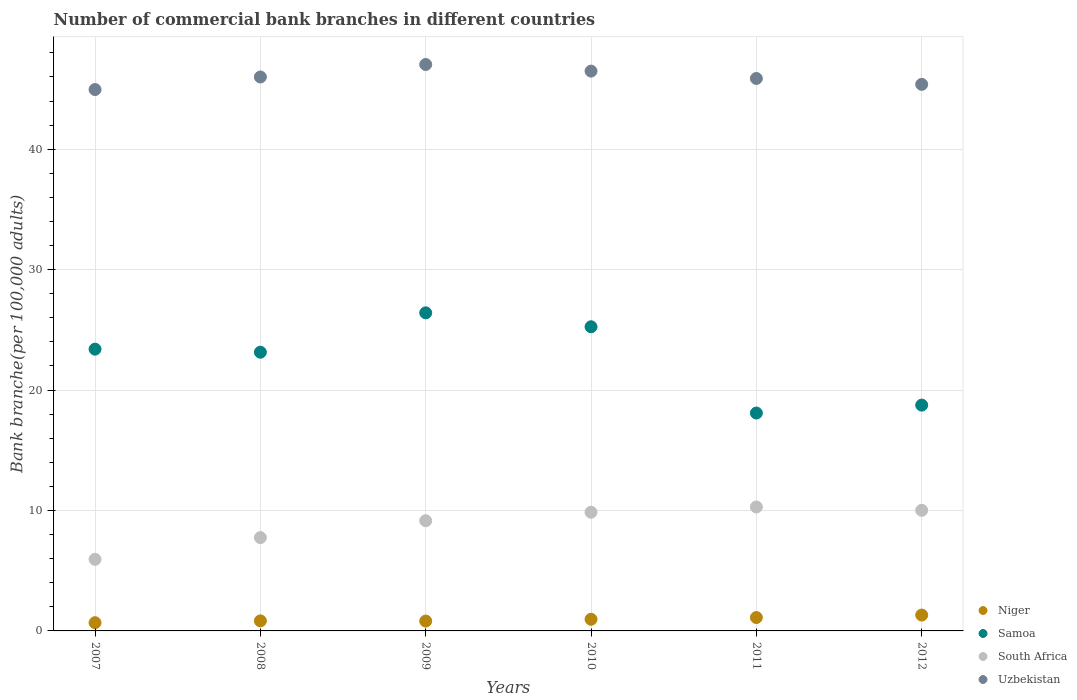How many different coloured dotlines are there?
Your answer should be very brief. 4. What is the number of commercial bank branches in Samoa in 2009?
Make the answer very short. 26.41. Across all years, what is the maximum number of commercial bank branches in Niger?
Your answer should be compact. 1.32. Across all years, what is the minimum number of commercial bank branches in Niger?
Make the answer very short. 0.68. In which year was the number of commercial bank branches in Niger maximum?
Ensure brevity in your answer.  2012. What is the total number of commercial bank branches in Uzbekistan in the graph?
Provide a short and direct response. 275.72. What is the difference between the number of commercial bank branches in South Africa in 2007 and that in 2012?
Your response must be concise. -4.07. What is the difference between the number of commercial bank branches in Samoa in 2010 and the number of commercial bank branches in South Africa in 2012?
Give a very brief answer. 15.24. What is the average number of commercial bank branches in South Africa per year?
Offer a terse response. 8.83. In the year 2009, what is the difference between the number of commercial bank branches in Samoa and number of commercial bank branches in Niger?
Offer a terse response. 25.59. What is the ratio of the number of commercial bank branches in Uzbekistan in 2007 to that in 2008?
Offer a terse response. 0.98. Is the difference between the number of commercial bank branches in Samoa in 2011 and 2012 greater than the difference between the number of commercial bank branches in Niger in 2011 and 2012?
Provide a succinct answer. No. What is the difference between the highest and the second highest number of commercial bank branches in South Africa?
Your answer should be very brief. 0.28. What is the difference between the highest and the lowest number of commercial bank branches in Uzbekistan?
Your answer should be compact. 2.08. Is the sum of the number of commercial bank branches in Uzbekistan in 2009 and 2010 greater than the maximum number of commercial bank branches in South Africa across all years?
Give a very brief answer. Yes. Is the number of commercial bank branches in Niger strictly greater than the number of commercial bank branches in Uzbekistan over the years?
Keep it short and to the point. No. Is the number of commercial bank branches in Uzbekistan strictly less than the number of commercial bank branches in Samoa over the years?
Provide a short and direct response. No. Does the graph contain any zero values?
Provide a succinct answer. No. Does the graph contain grids?
Give a very brief answer. Yes. How are the legend labels stacked?
Your answer should be very brief. Vertical. What is the title of the graph?
Make the answer very short. Number of commercial bank branches in different countries. Does "Croatia" appear as one of the legend labels in the graph?
Give a very brief answer. No. What is the label or title of the Y-axis?
Offer a terse response. Bank branche(per 100,0 adults). What is the Bank branche(per 100,000 adults) in Niger in 2007?
Provide a short and direct response. 0.68. What is the Bank branche(per 100,000 adults) of Samoa in 2007?
Give a very brief answer. 23.4. What is the Bank branche(per 100,000 adults) in South Africa in 2007?
Provide a short and direct response. 5.94. What is the Bank branche(per 100,000 adults) of Uzbekistan in 2007?
Give a very brief answer. 44.95. What is the Bank branche(per 100,000 adults) in Niger in 2008?
Your response must be concise. 0.83. What is the Bank branche(per 100,000 adults) in Samoa in 2008?
Offer a very short reply. 23.14. What is the Bank branche(per 100,000 adults) in South Africa in 2008?
Offer a terse response. 7.75. What is the Bank branche(per 100,000 adults) in Uzbekistan in 2008?
Give a very brief answer. 46. What is the Bank branche(per 100,000 adults) in Niger in 2009?
Offer a very short reply. 0.82. What is the Bank branche(per 100,000 adults) of Samoa in 2009?
Provide a short and direct response. 26.41. What is the Bank branche(per 100,000 adults) in South Africa in 2009?
Your answer should be very brief. 9.15. What is the Bank branche(per 100,000 adults) of Uzbekistan in 2009?
Provide a short and direct response. 47.03. What is the Bank branche(per 100,000 adults) of Niger in 2010?
Your answer should be very brief. 0.97. What is the Bank branche(per 100,000 adults) of Samoa in 2010?
Give a very brief answer. 25.26. What is the Bank branche(per 100,000 adults) of South Africa in 2010?
Make the answer very short. 9.85. What is the Bank branche(per 100,000 adults) in Uzbekistan in 2010?
Make the answer very short. 46.48. What is the Bank branche(per 100,000 adults) of Niger in 2011?
Offer a very short reply. 1.11. What is the Bank branche(per 100,000 adults) of Samoa in 2011?
Provide a short and direct response. 18.09. What is the Bank branche(per 100,000 adults) of South Africa in 2011?
Provide a short and direct response. 10.29. What is the Bank branche(per 100,000 adults) of Uzbekistan in 2011?
Provide a succinct answer. 45.87. What is the Bank branche(per 100,000 adults) in Niger in 2012?
Your answer should be compact. 1.32. What is the Bank branche(per 100,000 adults) in Samoa in 2012?
Provide a short and direct response. 18.75. What is the Bank branche(per 100,000 adults) in South Africa in 2012?
Your answer should be compact. 10.01. What is the Bank branche(per 100,000 adults) of Uzbekistan in 2012?
Your answer should be very brief. 45.38. Across all years, what is the maximum Bank branche(per 100,000 adults) of Niger?
Keep it short and to the point. 1.32. Across all years, what is the maximum Bank branche(per 100,000 adults) in Samoa?
Provide a short and direct response. 26.41. Across all years, what is the maximum Bank branche(per 100,000 adults) of South Africa?
Keep it short and to the point. 10.29. Across all years, what is the maximum Bank branche(per 100,000 adults) in Uzbekistan?
Provide a succinct answer. 47.03. Across all years, what is the minimum Bank branche(per 100,000 adults) of Niger?
Give a very brief answer. 0.68. Across all years, what is the minimum Bank branche(per 100,000 adults) in Samoa?
Offer a terse response. 18.09. Across all years, what is the minimum Bank branche(per 100,000 adults) in South Africa?
Your answer should be compact. 5.94. Across all years, what is the minimum Bank branche(per 100,000 adults) in Uzbekistan?
Make the answer very short. 44.95. What is the total Bank branche(per 100,000 adults) of Niger in the graph?
Offer a terse response. 5.73. What is the total Bank branche(per 100,000 adults) in Samoa in the graph?
Your answer should be compact. 135.05. What is the total Bank branche(per 100,000 adults) of South Africa in the graph?
Provide a short and direct response. 53. What is the total Bank branche(per 100,000 adults) in Uzbekistan in the graph?
Offer a terse response. 275.72. What is the difference between the Bank branche(per 100,000 adults) in Niger in 2007 and that in 2008?
Provide a short and direct response. -0.15. What is the difference between the Bank branche(per 100,000 adults) in Samoa in 2007 and that in 2008?
Your answer should be very brief. 0.26. What is the difference between the Bank branche(per 100,000 adults) of South Africa in 2007 and that in 2008?
Your answer should be very brief. -1.8. What is the difference between the Bank branche(per 100,000 adults) in Uzbekistan in 2007 and that in 2008?
Your answer should be very brief. -1.04. What is the difference between the Bank branche(per 100,000 adults) of Niger in 2007 and that in 2009?
Offer a terse response. -0.14. What is the difference between the Bank branche(per 100,000 adults) of Samoa in 2007 and that in 2009?
Your answer should be compact. -3.02. What is the difference between the Bank branche(per 100,000 adults) in South Africa in 2007 and that in 2009?
Your response must be concise. -3.2. What is the difference between the Bank branche(per 100,000 adults) of Uzbekistan in 2007 and that in 2009?
Your response must be concise. -2.08. What is the difference between the Bank branche(per 100,000 adults) in Niger in 2007 and that in 2010?
Your response must be concise. -0.28. What is the difference between the Bank branche(per 100,000 adults) in Samoa in 2007 and that in 2010?
Your answer should be very brief. -1.86. What is the difference between the Bank branche(per 100,000 adults) in South Africa in 2007 and that in 2010?
Keep it short and to the point. -3.91. What is the difference between the Bank branche(per 100,000 adults) of Uzbekistan in 2007 and that in 2010?
Your answer should be compact. -1.53. What is the difference between the Bank branche(per 100,000 adults) in Niger in 2007 and that in 2011?
Make the answer very short. -0.43. What is the difference between the Bank branche(per 100,000 adults) of Samoa in 2007 and that in 2011?
Make the answer very short. 5.31. What is the difference between the Bank branche(per 100,000 adults) in South Africa in 2007 and that in 2011?
Offer a very short reply. -4.35. What is the difference between the Bank branche(per 100,000 adults) of Uzbekistan in 2007 and that in 2011?
Your answer should be compact. -0.92. What is the difference between the Bank branche(per 100,000 adults) of Niger in 2007 and that in 2012?
Offer a terse response. -0.64. What is the difference between the Bank branche(per 100,000 adults) in Samoa in 2007 and that in 2012?
Make the answer very short. 4.65. What is the difference between the Bank branche(per 100,000 adults) in South Africa in 2007 and that in 2012?
Give a very brief answer. -4.07. What is the difference between the Bank branche(per 100,000 adults) of Uzbekistan in 2007 and that in 2012?
Keep it short and to the point. -0.43. What is the difference between the Bank branche(per 100,000 adults) of Niger in 2008 and that in 2009?
Provide a short and direct response. 0.02. What is the difference between the Bank branche(per 100,000 adults) in Samoa in 2008 and that in 2009?
Make the answer very short. -3.27. What is the difference between the Bank branche(per 100,000 adults) in South Africa in 2008 and that in 2009?
Give a very brief answer. -1.4. What is the difference between the Bank branche(per 100,000 adults) in Uzbekistan in 2008 and that in 2009?
Offer a very short reply. -1.04. What is the difference between the Bank branche(per 100,000 adults) of Niger in 2008 and that in 2010?
Offer a terse response. -0.13. What is the difference between the Bank branche(per 100,000 adults) of Samoa in 2008 and that in 2010?
Provide a short and direct response. -2.11. What is the difference between the Bank branche(per 100,000 adults) in South Africa in 2008 and that in 2010?
Your answer should be very brief. -2.11. What is the difference between the Bank branche(per 100,000 adults) in Uzbekistan in 2008 and that in 2010?
Your answer should be very brief. -0.49. What is the difference between the Bank branche(per 100,000 adults) of Niger in 2008 and that in 2011?
Keep it short and to the point. -0.28. What is the difference between the Bank branche(per 100,000 adults) of Samoa in 2008 and that in 2011?
Make the answer very short. 5.05. What is the difference between the Bank branche(per 100,000 adults) of South Africa in 2008 and that in 2011?
Your response must be concise. -2.54. What is the difference between the Bank branche(per 100,000 adults) in Uzbekistan in 2008 and that in 2011?
Offer a terse response. 0.12. What is the difference between the Bank branche(per 100,000 adults) in Niger in 2008 and that in 2012?
Offer a very short reply. -0.48. What is the difference between the Bank branche(per 100,000 adults) of Samoa in 2008 and that in 2012?
Provide a short and direct response. 4.39. What is the difference between the Bank branche(per 100,000 adults) of South Africa in 2008 and that in 2012?
Provide a short and direct response. -2.27. What is the difference between the Bank branche(per 100,000 adults) of Uzbekistan in 2008 and that in 2012?
Give a very brief answer. 0.61. What is the difference between the Bank branche(per 100,000 adults) of Niger in 2009 and that in 2010?
Your answer should be compact. -0.15. What is the difference between the Bank branche(per 100,000 adults) in Samoa in 2009 and that in 2010?
Make the answer very short. 1.16. What is the difference between the Bank branche(per 100,000 adults) in South Africa in 2009 and that in 2010?
Offer a very short reply. -0.71. What is the difference between the Bank branche(per 100,000 adults) of Uzbekistan in 2009 and that in 2010?
Provide a succinct answer. 0.55. What is the difference between the Bank branche(per 100,000 adults) of Niger in 2009 and that in 2011?
Keep it short and to the point. -0.29. What is the difference between the Bank branche(per 100,000 adults) in Samoa in 2009 and that in 2011?
Your answer should be compact. 8.32. What is the difference between the Bank branche(per 100,000 adults) in South Africa in 2009 and that in 2011?
Keep it short and to the point. -1.14. What is the difference between the Bank branche(per 100,000 adults) in Uzbekistan in 2009 and that in 2011?
Make the answer very short. 1.16. What is the difference between the Bank branche(per 100,000 adults) of Niger in 2009 and that in 2012?
Provide a succinct answer. -0.5. What is the difference between the Bank branche(per 100,000 adults) of Samoa in 2009 and that in 2012?
Your answer should be very brief. 7.66. What is the difference between the Bank branche(per 100,000 adults) of South Africa in 2009 and that in 2012?
Offer a terse response. -0.87. What is the difference between the Bank branche(per 100,000 adults) in Uzbekistan in 2009 and that in 2012?
Give a very brief answer. 1.65. What is the difference between the Bank branche(per 100,000 adults) of Niger in 2010 and that in 2011?
Provide a succinct answer. -0.15. What is the difference between the Bank branche(per 100,000 adults) of Samoa in 2010 and that in 2011?
Offer a very short reply. 7.16. What is the difference between the Bank branche(per 100,000 adults) in South Africa in 2010 and that in 2011?
Offer a very short reply. -0.44. What is the difference between the Bank branche(per 100,000 adults) in Uzbekistan in 2010 and that in 2011?
Provide a succinct answer. 0.61. What is the difference between the Bank branche(per 100,000 adults) of Niger in 2010 and that in 2012?
Your answer should be very brief. -0.35. What is the difference between the Bank branche(per 100,000 adults) of Samoa in 2010 and that in 2012?
Ensure brevity in your answer.  6.51. What is the difference between the Bank branche(per 100,000 adults) in South Africa in 2010 and that in 2012?
Your answer should be compact. -0.16. What is the difference between the Bank branche(per 100,000 adults) of Uzbekistan in 2010 and that in 2012?
Offer a very short reply. 1.1. What is the difference between the Bank branche(per 100,000 adults) of Niger in 2011 and that in 2012?
Provide a short and direct response. -0.2. What is the difference between the Bank branche(per 100,000 adults) in Samoa in 2011 and that in 2012?
Provide a succinct answer. -0.66. What is the difference between the Bank branche(per 100,000 adults) of South Africa in 2011 and that in 2012?
Give a very brief answer. 0.28. What is the difference between the Bank branche(per 100,000 adults) of Uzbekistan in 2011 and that in 2012?
Provide a short and direct response. 0.49. What is the difference between the Bank branche(per 100,000 adults) in Niger in 2007 and the Bank branche(per 100,000 adults) in Samoa in 2008?
Provide a short and direct response. -22.46. What is the difference between the Bank branche(per 100,000 adults) in Niger in 2007 and the Bank branche(per 100,000 adults) in South Africa in 2008?
Your answer should be very brief. -7.07. What is the difference between the Bank branche(per 100,000 adults) in Niger in 2007 and the Bank branche(per 100,000 adults) in Uzbekistan in 2008?
Offer a very short reply. -45.31. What is the difference between the Bank branche(per 100,000 adults) of Samoa in 2007 and the Bank branche(per 100,000 adults) of South Africa in 2008?
Provide a succinct answer. 15.65. What is the difference between the Bank branche(per 100,000 adults) of Samoa in 2007 and the Bank branche(per 100,000 adults) of Uzbekistan in 2008?
Your answer should be compact. -22.6. What is the difference between the Bank branche(per 100,000 adults) in South Africa in 2007 and the Bank branche(per 100,000 adults) in Uzbekistan in 2008?
Offer a terse response. -40.05. What is the difference between the Bank branche(per 100,000 adults) of Niger in 2007 and the Bank branche(per 100,000 adults) of Samoa in 2009?
Provide a short and direct response. -25.73. What is the difference between the Bank branche(per 100,000 adults) of Niger in 2007 and the Bank branche(per 100,000 adults) of South Africa in 2009?
Provide a short and direct response. -8.47. What is the difference between the Bank branche(per 100,000 adults) in Niger in 2007 and the Bank branche(per 100,000 adults) in Uzbekistan in 2009?
Keep it short and to the point. -46.35. What is the difference between the Bank branche(per 100,000 adults) in Samoa in 2007 and the Bank branche(per 100,000 adults) in South Africa in 2009?
Your answer should be compact. 14.25. What is the difference between the Bank branche(per 100,000 adults) of Samoa in 2007 and the Bank branche(per 100,000 adults) of Uzbekistan in 2009?
Provide a succinct answer. -23.64. What is the difference between the Bank branche(per 100,000 adults) in South Africa in 2007 and the Bank branche(per 100,000 adults) in Uzbekistan in 2009?
Keep it short and to the point. -41.09. What is the difference between the Bank branche(per 100,000 adults) in Niger in 2007 and the Bank branche(per 100,000 adults) in Samoa in 2010?
Provide a succinct answer. -24.57. What is the difference between the Bank branche(per 100,000 adults) in Niger in 2007 and the Bank branche(per 100,000 adults) in South Africa in 2010?
Your response must be concise. -9.17. What is the difference between the Bank branche(per 100,000 adults) in Niger in 2007 and the Bank branche(per 100,000 adults) in Uzbekistan in 2010?
Give a very brief answer. -45.8. What is the difference between the Bank branche(per 100,000 adults) in Samoa in 2007 and the Bank branche(per 100,000 adults) in South Africa in 2010?
Make the answer very short. 13.54. What is the difference between the Bank branche(per 100,000 adults) of Samoa in 2007 and the Bank branche(per 100,000 adults) of Uzbekistan in 2010?
Your response must be concise. -23.09. What is the difference between the Bank branche(per 100,000 adults) in South Africa in 2007 and the Bank branche(per 100,000 adults) in Uzbekistan in 2010?
Give a very brief answer. -40.54. What is the difference between the Bank branche(per 100,000 adults) of Niger in 2007 and the Bank branche(per 100,000 adults) of Samoa in 2011?
Make the answer very short. -17.41. What is the difference between the Bank branche(per 100,000 adults) of Niger in 2007 and the Bank branche(per 100,000 adults) of South Africa in 2011?
Provide a short and direct response. -9.61. What is the difference between the Bank branche(per 100,000 adults) of Niger in 2007 and the Bank branche(per 100,000 adults) of Uzbekistan in 2011?
Provide a short and direct response. -45.19. What is the difference between the Bank branche(per 100,000 adults) of Samoa in 2007 and the Bank branche(per 100,000 adults) of South Africa in 2011?
Provide a succinct answer. 13.11. What is the difference between the Bank branche(per 100,000 adults) in Samoa in 2007 and the Bank branche(per 100,000 adults) in Uzbekistan in 2011?
Make the answer very short. -22.48. What is the difference between the Bank branche(per 100,000 adults) of South Africa in 2007 and the Bank branche(per 100,000 adults) of Uzbekistan in 2011?
Offer a terse response. -39.93. What is the difference between the Bank branche(per 100,000 adults) of Niger in 2007 and the Bank branche(per 100,000 adults) of Samoa in 2012?
Provide a short and direct response. -18.07. What is the difference between the Bank branche(per 100,000 adults) in Niger in 2007 and the Bank branche(per 100,000 adults) in South Africa in 2012?
Your answer should be compact. -9.33. What is the difference between the Bank branche(per 100,000 adults) in Niger in 2007 and the Bank branche(per 100,000 adults) in Uzbekistan in 2012?
Offer a terse response. -44.7. What is the difference between the Bank branche(per 100,000 adults) of Samoa in 2007 and the Bank branche(per 100,000 adults) of South Africa in 2012?
Provide a short and direct response. 13.38. What is the difference between the Bank branche(per 100,000 adults) in Samoa in 2007 and the Bank branche(per 100,000 adults) in Uzbekistan in 2012?
Your response must be concise. -21.99. What is the difference between the Bank branche(per 100,000 adults) in South Africa in 2007 and the Bank branche(per 100,000 adults) in Uzbekistan in 2012?
Keep it short and to the point. -39.44. What is the difference between the Bank branche(per 100,000 adults) of Niger in 2008 and the Bank branche(per 100,000 adults) of Samoa in 2009?
Provide a succinct answer. -25.58. What is the difference between the Bank branche(per 100,000 adults) of Niger in 2008 and the Bank branche(per 100,000 adults) of South Africa in 2009?
Provide a short and direct response. -8.31. What is the difference between the Bank branche(per 100,000 adults) in Niger in 2008 and the Bank branche(per 100,000 adults) in Uzbekistan in 2009?
Offer a very short reply. -46.2. What is the difference between the Bank branche(per 100,000 adults) in Samoa in 2008 and the Bank branche(per 100,000 adults) in South Africa in 2009?
Make the answer very short. 13.99. What is the difference between the Bank branche(per 100,000 adults) of Samoa in 2008 and the Bank branche(per 100,000 adults) of Uzbekistan in 2009?
Your response must be concise. -23.89. What is the difference between the Bank branche(per 100,000 adults) in South Africa in 2008 and the Bank branche(per 100,000 adults) in Uzbekistan in 2009?
Give a very brief answer. -39.29. What is the difference between the Bank branche(per 100,000 adults) of Niger in 2008 and the Bank branche(per 100,000 adults) of Samoa in 2010?
Give a very brief answer. -24.42. What is the difference between the Bank branche(per 100,000 adults) of Niger in 2008 and the Bank branche(per 100,000 adults) of South Africa in 2010?
Give a very brief answer. -9.02. What is the difference between the Bank branche(per 100,000 adults) of Niger in 2008 and the Bank branche(per 100,000 adults) of Uzbekistan in 2010?
Provide a short and direct response. -45.65. What is the difference between the Bank branche(per 100,000 adults) in Samoa in 2008 and the Bank branche(per 100,000 adults) in South Africa in 2010?
Keep it short and to the point. 13.29. What is the difference between the Bank branche(per 100,000 adults) of Samoa in 2008 and the Bank branche(per 100,000 adults) of Uzbekistan in 2010?
Offer a terse response. -23.34. What is the difference between the Bank branche(per 100,000 adults) of South Africa in 2008 and the Bank branche(per 100,000 adults) of Uzbekistan in 2010?
Give a very brief answer. -38.73. What is the difference between the Bank branche(per 100,000 adults) of Niger in 2008 and the Bank branche(per 100,000 adults) of Samoa in 2011?
Offer a very short reply. -17.26. What is the difference between the Bank branche(per 100,000 adults) in Niger in 2008 and the Bank branche(per 100,000 adults) in South Africa in 2011?
Keep it short and to the point. -9.46. What is the difference between the Bank branche(per 100,000 adults) in Niger in 2008 and the Bank branche(per 100,000 adults) in Uzbekistan in 2011?
Keep it short and to the point. -45.04. What is the difference between the Bank branche(per 100,000 adults) of Samoa in 2008 and the Bank branche(per 100,000 adults) of South Africa in 2011?
Make the answer very short. 12.85. What is the difference between the Bank branche(per 100,000 adults) of Samoa in 2008 and the Bank branche(per 100,000 adults) of Uzbekistan in 2011?
Provide a succinct answer. -22.73. What is the difference between the Bank branche(per 100,000 adults) of South Africa in 2008 and the Bank branche(per 100,000 adults) of Uzbekistan in 2011?
Give a very brief answer. -38.12. What is the difference between the Bank branche(per 100,000 adults) in Niger in 2008 and the Bank branche(per 100,000 adults) in Samoa in 2012?
Make the answer very short. -17.92. What is the difference between the Bank branche(per 100,000 adults) of Niger in 2008 and the Bank branche(per 100,000 adults) of South Africa in 2012?
Your answer should be compact. -9.18. What is the difference between the Bank branche(per 100,000 adults) of Niger in 2008 and the Bank branche(per 100,000 adults) of Uzbekistan in 2012?
Offer a terse response. -44.55. What is the difference between the Bank branche(per 100,000 adults) of Samoa in 2008 and the Bank branche(per 100,000 adults) of South Africa in 2012?
Offer a terse response. 13.13. What is the difference between the Bank branche(per 100,000 adults) in Samoa in 2008 and the Bank branche(per 100,000 adults) in Uzbekistan in 2012?
Ensure brevity in your answer.  -22.24. What is the difference between the Bank branche(per 100,000 adults) in South Africa in 2008 and the Bank branche(per 100,000 adults) in Uzbekistan in 2012?
Provide a short and direct response. -37.64. What is the difference between the Bank branche(per 100,000 adults) of Niger in 2009 and the Bank branche(per 100,000 adults) of Samoa in 2010?
Your response must be concise. -24.44. What is the difference between the Bank branche(per 100,000 adults) in Niger in 2009 and the Bank branche(per 100,000 adults) in South Africa in 2010?
Make the answer very short. -9.04. What is the difference between the Bank branche(per 100,000 adults) in Niger in 2009 and the Bank branche(per 100,000 adults) in Uzbekistan in 2010?
Offer a terse response. -45.66. What is the difference between the Bank branche(per 100,000 adults) in Samoa in 2009 and the Bank branche(per 100,000 adults) in South Africa in 2010?
Keep it short and to the point. 16.56. What is the difference between the Bank branche(per 100,000 adults) in Samoa in 2009 and the Bank branche(per 100,000 adults) in Uzbekistan in 2010?
Offer a terse response. -20.07. What is the difference between the Bank branche(per 100,000 adults) of South Africa in 2009 and the Bank branche(per 100,000 adults) of Uzbekistan in 2010?
Offer a very short reply. -37.34. What is the difference between the Bank branche(per 100,000 adults) in Niger in 2009 and the Bank branche(per 100,000 adults) in Samoa in 2011?
Offer a very short reply. -17.27. What is the difference between the Bank branche(per 100,000 adults) in Niger in 2009 and the Bank branche(per 100,000 adults) in South Africa in 2011?
Ensure brevity in your answer.  -9.47. What is the difference between the Bank branche(per 100,000 adults) of Niger in 2009 and the Bank branche(per 100,000 adults) of Uzbekistan in 2011?
Provide a succinct answer. -45.05. What is the difference between the Bank branche(per 100,000 adults) in Samoa in 2009 and the Bank branche(per 100,000 adults) in South Africa in 2011?
Provide a succinct answer. 16.12. What is the difference between the Bank branche(per 100,000 adults) in Samoa in 2009 and the Bank branche(per 100,000 adults) in Uzbekistan in 2011?
Your answer should be compact. -19.46. What is the difference between the Bank branche(per 100,000 adults) of South Africa in 2009 and the Bank branche(per 100,000 adults) of Uzbekistan in 2011?
Your response must be concise. -36.73. What is the difference between the Bank branche(per 100,000 adults) of Niger in 2009 and the Bank branche(per 100,000 adults) of Samoa in 2012?
Your response must be concise. -17.93. What is the difference between the Bank branche(per 100,000 adults) in Niger in 2009 and the Bank branche(per 100,000 adults) in South Africa in 2012?
Offer a very short reply. -9.2. What is the difference between the Bank branche(per 100,000 adults) in Niger in 2009 and the Bank branche(per 100,000 adults) in Uzbekistan in 2012?
Provide a short and direct response. -44.57. What is the difference between the Bank branche(per 100,000 adults) of Samoa in 2009 and the Bank branche(per 100,000 adults) of South Africa in 2012?
Provide a short and direct response. 16.4. What is the difference between the Bank branche(per 100,000 adults) in Samoa in 2009 and the Bank branche(per 100,000 adults) in Uzbekistan in 2012?
Offer a very short reply. -18.97. What is the difference between the Bank branche(per 100,000 adults) of South Africa in 2009 and the Bank branche(per 100,000 adults) of Uzbekistan in 2012?
Offer a terse response. -36.24. What is the difference between the Bank branche(per 100,000 adults) of Niger in 2010 and the Bank branche(per 100,000 adults) of Samoa in 2011?
Your response must be concise. -17.13. What is the difference between the Bank branche(per 100,000 adults) in Niger in 2010 and the Bank branche(per 100,000 adults) in South Africa in 2011?
Offer a terse response. -9.33. What is the difference between the Bank branche(per 100,000 adults) in Niger in 2010 and the Bank branche(per 100,000 adults) in Uzbekistan in 2011?
Ensure brevity in your answer.  -44.91. What is the difference between the Bank branche(per 100,000 adults) in Samoa in 2010 and the Bank branche(per 100,000 adults) in South Africa in 2011?
Provide a succinct answer. 14.96. What is the difference between the Bank branche(per 100,000 adults) of Samoa in 2010 and the Bank branche(per 100,000 adults) of Uzbekistan in 2011?
Offer a terse response. -20.62. What is the difference between the Bank branche(per 100,000 adults) of South Africa in 2010 and the Bank branche(per 100,000 adults) of Uzbekistan in 2011?
Provide a short and direct response. -36.02. What is the difference between the Bank branche(per 100,000 adults) in Niger in 2010 and the Bank branche(per 100,000 adults) in Samoa in 2012?
Your answer should be very brief. -17.78. What is the difference between the Bank branche(per 100,000 adults) in Niger in 2010 and the Bank branche(per 100,000 adults) in South Africa in 2012?
Your answer should be very brief. -9.05. What is the difference between the Bank branche(per 100,000 adults) of Niger in 2010 and the Bank branche(per 100,000 adults) of Uzbekistan in 2012?
Provide a short and direct response. -44.42. What is the difference between the Bank branche(per 100,000 adults) of Samoa in 2010 and the Bank branche(per 100,000 adults) of South Africa in 2012?
Provide a succinct answer. 15.24. What is the difference between the Bank branche(per 100,000 adults) in Samoa in 2010 and the Bank branche(per 100,000 adults) in Uzbekistan in 2012?
Offer a terse response. -20.13. What is the difference between the Bank branche(per 100,000 adults) in South Africa in 2010 and the Bank branche(per 100,000 adults) in Uzbekistan in 2012?
Make the answer very short. -35.53. What is the difference between the Bank branche(per 100,000 adults) in Niger in 2011 and the Bank branche(per 100,000 adults) in Samoa in 2012?
Your answer should be very brief. -17.64. What is the difference between the Bank branche(per 100,000 adults) of Niger in 2011 and the Bank branche(per 100,000 adults) of South Africa in 2012?
Your answer should be very brief. -8.9. What is the difference between the Bank branche(per 100,000 adults) in Niger in 2011 and the Bank branche(per 100,000 adults) in Uzbekistan in 2012?
Ensure brevity in your answer.  -44.27. What is the difference between the Bank branche(per 100,000 adults) of Samoa in 2011 and the Bank branche(per 100,000 adults) of South Africa in 2012?
Your answer should be compact. 8.08. What is the difference between the Bank branche(per 100,000 adults) of Samoa in 2011 and the Bank branche(per 100,000 adults) of Uzbekistan in 2012?
Give a very brief answer. -27.29. What is the difference between the Bank branche(per 100,000 adults) in South Africa in 2011 and the Bank branche(per 100,000 adults) in Uzbekistan in 2012?
Your answer should be very brief. -35.09. What is the average Bank branche(per 100,000 adults) of Niger per year?
Ensure brevity in your answer.  0.95. What is the average Bank branche(per 100,000 adults) of Samoa per year?
Offer a terse response. 22.51. What is the average Bank branche(per 100,000 adults) of South Africa per year?
Provide a short and direct response. 8.83. What is the average Bank branche(per 100,000 adults) in Uzbekistan per year?
Your answer should be compact. 45.95. In the year 2007, what is the difference between the Bank branche(per 100,000 adults) in Niger and Bank branche(per 100,000 adults) in Samoa?
Your answer should be very brief. -22.72. In the year 2007, what is the difference between the Bank branche(per 100,000 adults) of Niger and Bank branche(per 100,000 adults) of South Africa?
Your response must be concise. -5.26. In the year 2007, what is the difference between the Bank branche(per 100,000 adults) of Niger and Bank branche(per 100,000 adults) of Uzbekistan?
Your response must be concise. -44.27. In the year 2007, what is the difference between the Bank branche(per 100,000 adults) in Samoa and Bank branche(per 100,000 adults) in South Africa?
Provide a short and direct response. 17.45. In the year 2007, what is the difference between the Bank branche(per 100,000 adults) of Samoa and Bank branche(per 100,000 adults) of Uzbekistan?
Offer a very short reply. -21.56. In the year 2007, what is the difference between the Bank branche(per 100,000 adults) of South Africa and Bank branche(per 100,000 adults) of Uzbekistan?
Provide a short and direct response. -39.01. In the year 2008, what is the difference between the Bank branche(per 100,000 adults) in Niger and Bank branche(per 100,000 adults) in Samoa?
Give a very brief answer. -22.31. In the year 2008, what is the difference between the Bank branche(per 100,000 adults) in Niger and Bank branche(per 100,000 adults) in South Africa?
Your answer should be very brief. -6.91. In the year 2008, what is the difference between the Bank branche(per 100,000 adults) of Niger and Bank branche(per 100,000 adults) of Uzbekistan?
Your response must be concise. -45.16. In the year 2008, what is the difference between the Bank branche(per 100,000 adults) of Samoa and Bank branche(per 100,000 adults) of South Africa?
Keep it short and to the point. 15.39. In the year 2008, what is the difference between the Bank branche(per 100,000 adults) of Samoa and Bank branche(per 100,000 adults) of Uzbekistan?
Your answer should be compact. -22.85. In the year 2008, what is the difference between the Bank branche(per 100,000 adults) in South Africa and Bank branche(per 100,000 adults) in Uzbekistan?
Your response must be concise. -38.25. In the year 2009, what is the difference between the Bank branche(per 100,000 adults) in Niger and Bank branche(per 100,000 adults) in Samoa?
Keep it short and to the point. -25.59. In the year 2009, what is the difference between the Bank branche(per 100,000 adults) in Niger and Bank branche(per 100,000 adults) in South Africa?
Offer a very short reply. -8.33. In the year 2009, what is the difference between the Bank branche(per 100,000 adults) in Niger and Bank branche(per 100,000 adults) in Uzbekistan?
Provide a succinct answer. -46.22. In the year 2009, what is the difference between the Bank branche(per 100,000 adults) of Samoa and Bank branche(per 100,000 adults) of South Africa?
Your response must be concise. 17.26. In the year 2009, what is the difference between the Bank branche(per 100,000 adults) in Samoa and Bank branche(per 100,000 adults) in Uzbekistan?
Offer a very short reply. -20.62. In the year 2009, what is the difference between the Bank branche(per 100,000 adults) in South Africa and Bank branche(per 100,000 adults) in Uzbekistan?
Provide a succinct answer. -37.89. In the year 2010, what is the difference between the Bank branche(per 100,000 adults) in Niger and Bank branche(per 100,000 adults) in Samoa?
Ensure brevity in your answer.  -24.29. In the year 2010, what is the difference between the Bank branche(per 100,000 adults) in Niger and Bank branche(per 100,000 adults) in South Africa?
Provide a succinct answer. -8.89. In the year 2010, what is the difference between the Bank branche(per 100,000 adults) of Niger and Bank branche(per 100,000 adults) of Uzbekistan?
Offer a terse response. -45.52. In the year 2010, what is the difference between the Bank branche(per 100,000 adults) in Samoa and Bank branche(per 100,000 adults) in South Africa?
Your answer should be very brief. 15.4. In the year 2010, what is the difference between the Bank branche(per 100,000 adults) in Samoa and Bank branche(per 100,000 adults) in Uzbekistan?
Offer a terse response. -21.23. In the year 2010, what is the difference between the Bank branche(per 100,000 adults) in South Africa and Bank branche(per 100,000 adults) in Uzbekistan?
Make the answer very short. -36.63. In the year 2011, what is the difference between the Bank branche(per 100,000 adults) of Niger and Bank branche(per 100,000 adults) of Samoa?
Keep it short and to the point. -16.98. In the year 2011, what is the difference between the Bank branche(per 100,000 adults) in Niger and Bank branche(per 100,000 adults) in South Africa?
Make the answer very short. -9.18. In the year 2011, what is the difference between the Bank branche(per 100,000 adults) of Niger and Bank branche(per 100,000 adults) of Uzbekistan?
Offer a very short reply. -44.76. In the year 2011, what is the difference between the Bank branche(per 100,000 adults) of Samoa and Bank branche(per 100,000 adults) of South Africa?
Offer a very short reply. 7.8. In the year 2011, what is the difference between the Bank branche(per 100,000 adults) of Samoa and Bank branche(per 100,000 adults) of Uzbekistan?
Your response must be concise. -27.78. In the year 2011, what is the difference between the Bank branche(per 100,000 adults) in South Africa and Bank branche(per 100,000 adults) in Uzbekistan?
Offer a terse response. -35.58. In the year 2012, what is the difference between the Bank branche(per 100,000 adults) in Niger and Bank branche(per 100,000 adults) in Samoa?
Your answer should be very brief. -17.43. In the year 2012, what is the difference between the Bank branche(per 100,000 adults) in Niger and Bank branche(per 100,000 adults) in South Africa?
Give a very brief answer. -8.7. In the year 2012, what is the difference between the Bank branche(per 100,000 adults) of Niger and Bank branche(per 100,000 adults) of Uzbekistan?
Give a very brief answer. -44.07. In the year 2012, what is the difference between the Bank branche(per 100,000 adults) in Samoa and Bank branche(per 100,000 adults) in South Africa?
Keep it short and to the point. 8.74. In the year 2012, what is the difference between the Bank branche(per 100,000 adults) of Samoa and Bank branche(per 100,000 adults) of Uzbekistan?
Provide a succinct answer. -26.63. In the year 2012, what is the difference between the Bank branche(per 100,000 adults) of South Africa and Bank branche(per 100,000 adults) of Uzbekistan?
Make the answer very short. -35.37. What is the ratio of the Bank branche(per 100,000 adults) in Niger in 2007 to that in 2008?
Give a very brief answer. 0.82. What is the ratio of the Bank branche(per 100,000 adults) in South Africa in 2007 to that in 2008?
Offer a terse response. 0.77. What is the ratio of the Bank branche(per 100,000 adults) in Uzbekistan in 2007 to that in 2008?
Provide a short and direct response. 0.98. What is the ratio of the Bank branche(per 100,000 adults) of Niger in 2007 to that in 2009?
Make the answer very short. 0.83. What is the ratio of the Bank branche(per 100,000 adults) in Samoa in 2007 to that in 2009?
Provide a short and direct response. 0.89. What is the ratio of the Bank branche(per 100,000 adults) of South Africa in 2007 to that in 2009?
Your response must be concise. 0.65. What is the ratio of the Bank branche(per 100,000 adults) in Uzbekistan in 2007 to that in 2009?
Your answer should be compact. 0.96. What is the ratio of the Bank branche(per 100,000 adults) in Niger in 2007 to that in 2010?
Give a very brief answer. 0.71. What is the ratio of the Bank branche(per 100,000 adults) in Samoa in 2007 to that in 2010?
Give a very brief answer. 0.93. What is the ratio of the Bank branche(per 100,000 adults) of South Africa in 2007 to that in 2010?
Keep it short and to the point. 0.6. What is the ratio of the Bank branche(per 100,000 adults) of Uzbekistan in 2007 to that in 2010?
Offer a terse response. 0.97. What is the ratio of the Bank branche(per 100,000 adults) in Niger in 2007 to that in 2011?
Make the answer very short. 0.61. What is the ratio of the Bank branche(per 100,000 adults) of Samoa in 2007 to that in 2011?
Give a very brief answer. 1.29. What is the ratio of the Bank branche(per 100,000 adults) in South Africa in 2007 to that in 2011?
Make the answer very short. 0.58. What is the ratio of the Bank branche(per 100,000 adults) of Uzbekistan in 2007 to that in 2011?
Your answer should be compact. 0.98. What is the ratio of the Bank branche(per 100,000 adults) in Niger in 2007 to that in 2012?
Make the answer very short. 0.52. What is the ratio of the Bank branche(per 100,000 adults) of Samoa in 2007 to that in 2012?
Offer a terse response. 1.25. What is the ratio of the Bank branche(per 100,000 adults) in South Africa in 2007 to that in 2012?
Make the answer very short. 0.59. What is the ratio of the Bank branche(per 100,000 adults) in Niger in 2008 to that in 2009?
Make the answer very short. 1.02. What is the ratio of the Bank branche(per 100,000 adults) of Samoa in 2008 to that in 2009?
Provide a succinct answer. 0.88. What is the ratio of the Bank branche(per 100,000 adults) of South Africa in 2008 to that in 2009?
Provide a succinct answer. 0.85. What is the ratio of the Bank branche(per 100,000 adults) in Uzbekistan in 2008 to that in 2009?
Your answer should be compact. 0.98. What is the ratio of the Bank branche(per 100,000 adults) of Niger in 2008 to that in 2010?
Your answer should be very brief. 0.86. What is the ratio of the Bank branche(per 100,000 adults) in Samoa in 2008 to that in 2010?
Ensure brevity in your answer.  0.92. What is the ratio of the Bank branche(per 100,000 adults) in South Africa in 2008 to that in 2010?
Your answer should be very brief. 0.79. What is the ratio of the Bank branche(per 100,000 adults) of Niger in 2008 to that in 2011?
Your answer should be compact. 0.75. What is the ratio of the Bank branche(per 100,000 adults) of Samoa in 2008 to that in 2011?
Your answer should be very brief. 1.28. What is the ratio of the Bank branche(per 100,000 adults) in South Africa in 2008 to that in 2011?
Your response must be concise. 0.75. What is the ratio of the Bank branche(per 100,000 adults) of Niger in 2008 to that in 2012?
Your answer should be compact. 0.63. What is the ratio of the Bank branche(per 100,000 adults) of Samoa in 2008 to that in 2012?
Provide a succinct answer. 1.23. What is the ratio of the Bank branche(per 100,000 adults) in South Africa in 2008 to that in 2012?
Your answer should be very brief. 0.77. What is the ratio of the Bank branche(per 100,000 adults) of Uzbekistan in 2008 to that in 2012?
Offer a terse response. 1.01. What is the ratio of the Bank branche(per 100,000 adults) in Niger in 2009 to that in 2010?
Ensure brevity in your answer.  0.85. What is the ratio of the Bank branche(per 100,000 adults) in Samoa in 2009 to that in 2010?
Your answer should be compact. 1.05. What is the ratio of the Bank branche(per 100,000 adults) of South Africa in 2009 to that in 2010?
Your answer should be compact. 0.93. What is the ratio of the Bank branche(per 100,000 adults) of Uzbekistan in 2009 to that in 2010?
Keep it short and to the point. 1.01. What is the ratio of the Bank branche(per 100,000 adults) in Niger in 2009 to that in 2011?
Your response must be concise. 0.74. What is the ratio of the Bank branche(per 100,000 adults) of Samoa in 2009 to that in 2011?
Make the answer very short. 1.46. What is the ratio of the Bank branche(per 100,000 adults) of South Africa in 2009 to that in 2011?
Offer a terse response. 0.89. What is the ratio of the Bank branche(per 100,000 adults) in Uzbekistan in 2009 to that in 2011?
Give a very brief answer. 1.03. What is the ratio of the Bank branche(per 100,000 adults) of Niger in 2009 to that in 2012?
Provide a succinct answer. 0.62. What is the ratio of the Bank branche(per 100,000 adults) of Samoa in 2009 to that in 2012?
Ensure brevity in your answer.  1.41. What is the ratio of the Bank branche(per 100,000 adults) of South Africa in 2009 to that in 2012?
Your response must be concise. 0.91. What is the ratio of the Bank branche(per 100,000 adults) in Uzbekistan in 2009 to that in 2012?
Keep it short and to the point. 1.04. What is the ratio of the Bank branche(per 100,000 adults) in Niger in 2010 to that in 2011?
Provide a short and direct response. 0.87. What is the ratio of the Bank branche(per 100,000 adults) of Samoa in 2010 to that in 2011?
Provide a succinct answer. 1.4. What is the ratio of the Bank branche(per 100,000 adults) of South Africa in 2010 to that in 2011?
Keep it short and to the point. 0.96. What is the ratio of the Bank branche(per 100,000 adults) of Uzbekistan in 2010 to that in 2011?
Your answer should be compact. 1.01. What is the ratio of the Bank branche(per 100,000 adults) of Niger in 2010 to that in 2012?
Ensure brevity in your answer.  0.73. What is the ratio of the Bank branche(per 100,000 adults) in Samoa in 2010 to that in 2012?
Your response must be concise. 1.35. What is the ratio of the Bank branche(per 100,000 adults) in South Africa in 2010 to that in 2012?
Give a very brief answer. 0.98. What is the ratio of the Bank branche(per 100,000 adults) in Uzbekistan in 2010 to that in 2012?
Offer a very short reply. 1.02. What is the ratio of the Bank branche(per 100,000 adults) of Niger in 2011 to that in 2012?
Your answer should be compact. 0.84. What is the ratio of the Bank branche(per 100,000 adults) of Samoa in 2011 to that in 2012?
Give a very brief answer. 0.96. What is the ratio of the Bank branche(per 100,000 adults) in South Africa in 2011 to that in 2012?
Your answer should be very brief. 1.03. What is the ratio of the Bank branche(per 100,000 adults) of Uzbekistan in 2011 to that in 2012?
Provide a succinct answer. 1.01. What is the difference between the highest and the second highest Bank branche(per 100,000 adults) of Niger?
Keep it short and to the point. 0.2. What is the difference between the highest and the second highest Bank branche(per 100,000 adults) of Samoa?
Offer a very short reply. 1.16. What is the difference between the highest and the second highest Bank branche(per 100,000 adults) in South Africa?
Provide a succinct answer. 0.28. What is the difference between the highest and the second highest Bank branche(per 100,000 adults) in Uzbekistan?
Your response must be concise. 0.55. What is the difference between the highest and the lowest Bank branche(per 100,000 adults) of Niger?
Provide a succinct answer. 0.64. What is the difference between the highest and the lowest Bank branche(per 100,000 adults) in Samoa?
Offer a terse response. 8.32. What is the difference between the highest and the lowest Bank branche(per 100,000 adults) of South Africa?
Provide a succinct answer. 4.35. What is the difference between the highest and the lowest Bank branche(per 100,000 adults) of Uzbekistan?
Give a very brief answer. 2.08. 